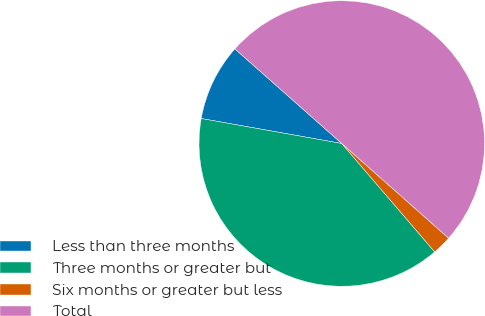Convert chart to OTSL. <chart><loc_0><loc_0><loc_500><loc_500><pie_chart><fcel>Less than three months<fcel>Three months or greater but<fcel>Six months or greater but less<fcel>Total<nl><fcel>8.73%<fcel>39.08%<fcel>2.18%<fcel>50.0%<nl></chart> 